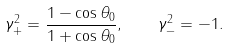Convert formula to latex. <formula><loc_0><loc_0><loc_500><loc_500>\gamma _ { + } ^ { 2 } = \frac { 1 - \cos \theta _ { 0 } } { 1 + \cos \theta _ { 0 } } , \quad \gamma _ { - } ^ { 2 } = - 1 .</formula> 